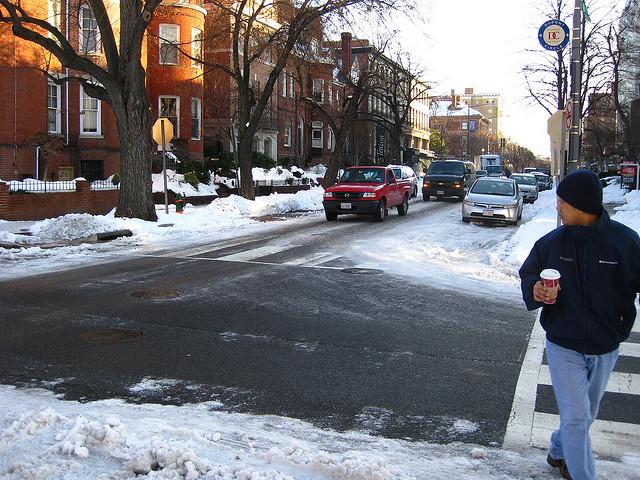Is there a red truck on the road?
Answer briefly. Yes. Is it summer time?
Give a very brief answer. No. What is the name of the company selling the house?
Be succinct. Realty. 